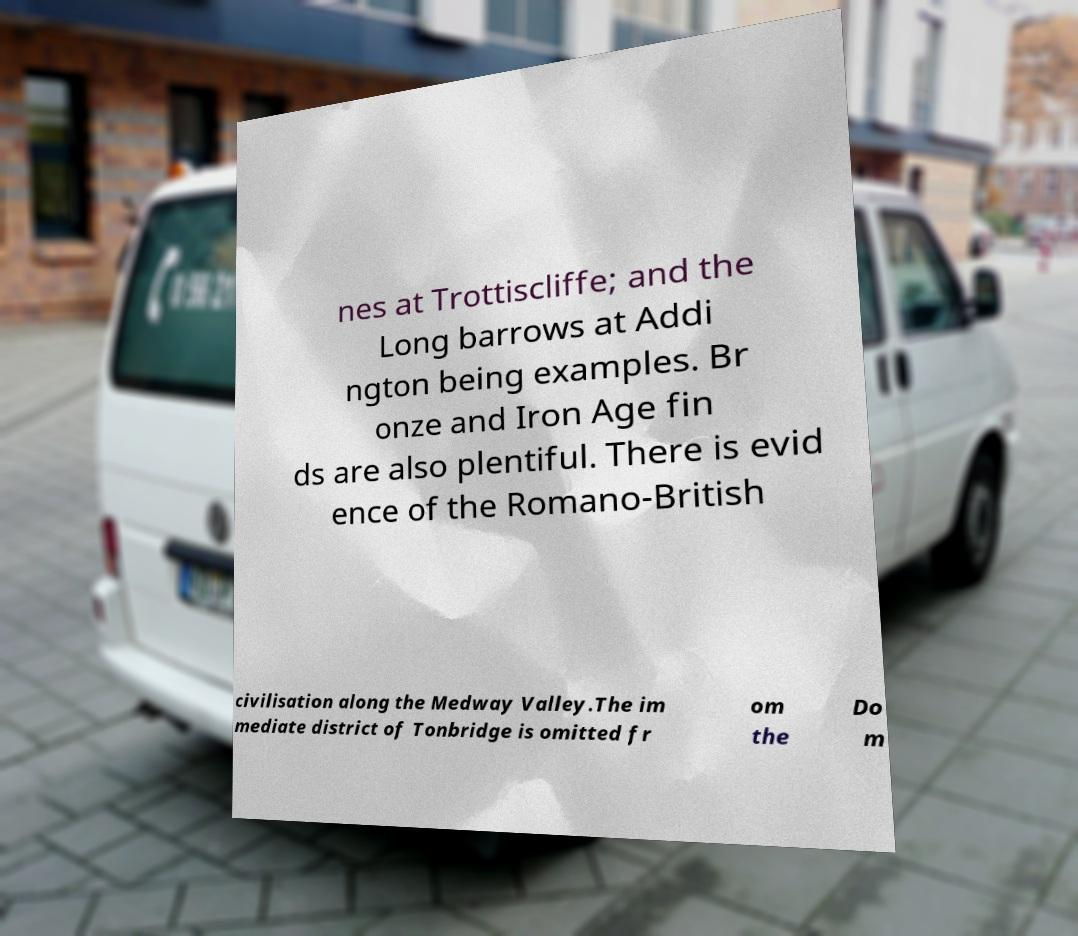Could you assist in decoding the text presented in this image and type it out clearly? nes at Trottiscliffe; and the Long barrows at Addi ngton being examples. Br onze and Iron Age fin ds are also plentiful. There is evid ence of the Romano-British civilisation along the Medway Valley.The im mediate district of Tonbridge is omitted fr om the Do m 